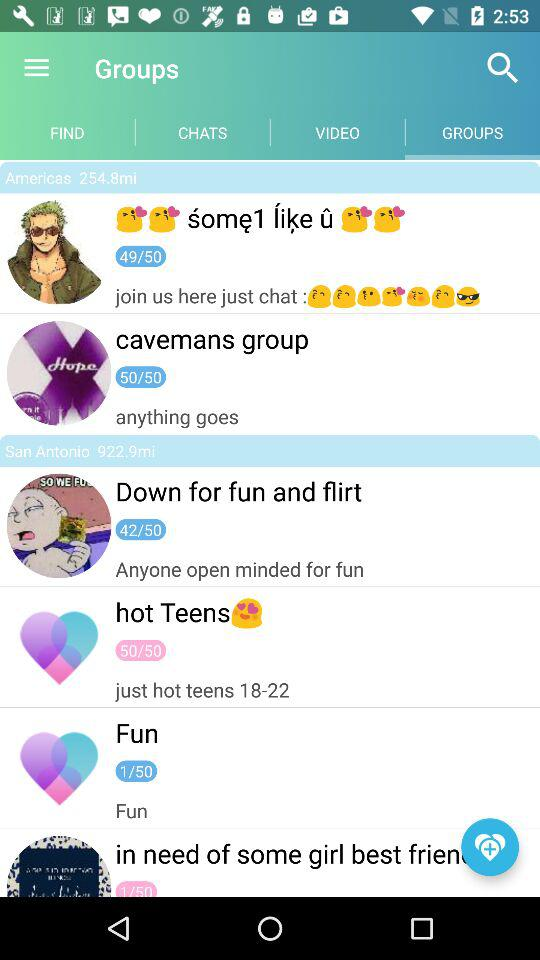What tab is selected? The selected tab is "GROUPS". 